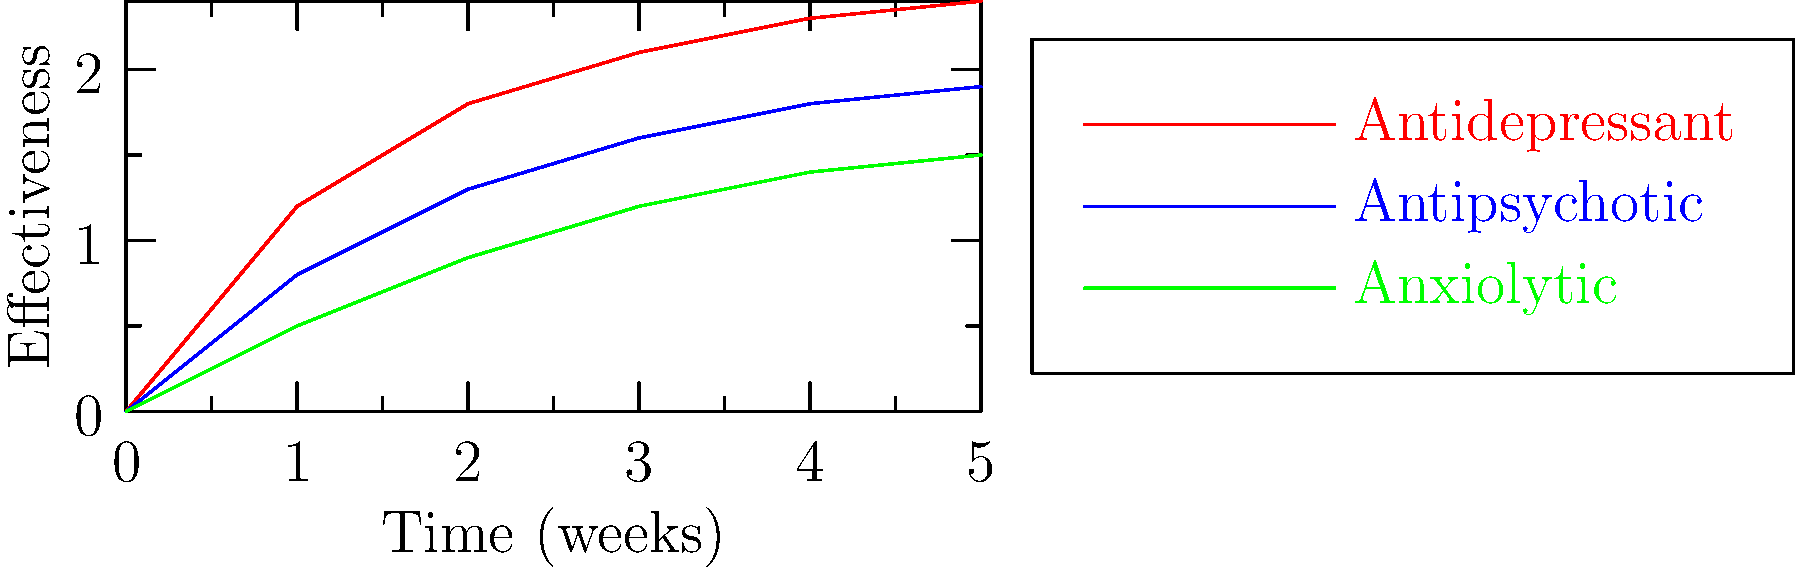Analyze the graph depicting the effectiveness of three psychotropic medications over time. Which medication shows the most rapid increase in effectiveness during the first two weeks of treatment? To determine which medication shows the most rapid increase in effectiveness during the first two weeks of treatment, we need to examine the slopes of each line from week 0 to week 2:

1. Antidepressant (red line):
   Effectiveness at week 0: 0
   Effectiveness at week 2: 1.8
   Increase: 1.8 - 0 = 1.8

2. Antipsychotic (blue line):
   Effectiveness at week 0: 0
   Effectiveness at week 2: 1.3
   Increase: 1.3 - 0 = 1.3

3. Anxiolytic (green line):
   Effectiveness at week 0: 0
   Effectiveness at week 2: 0.9
   Increase: 0.9 - 0 = 0.9

The antidepressant shows the steepest slope and the largest increase in effectiveness (1.8) during the first two weeks, indicating the most rapid increase in effectiveness among the three medications.
Answer: Antidepressant 